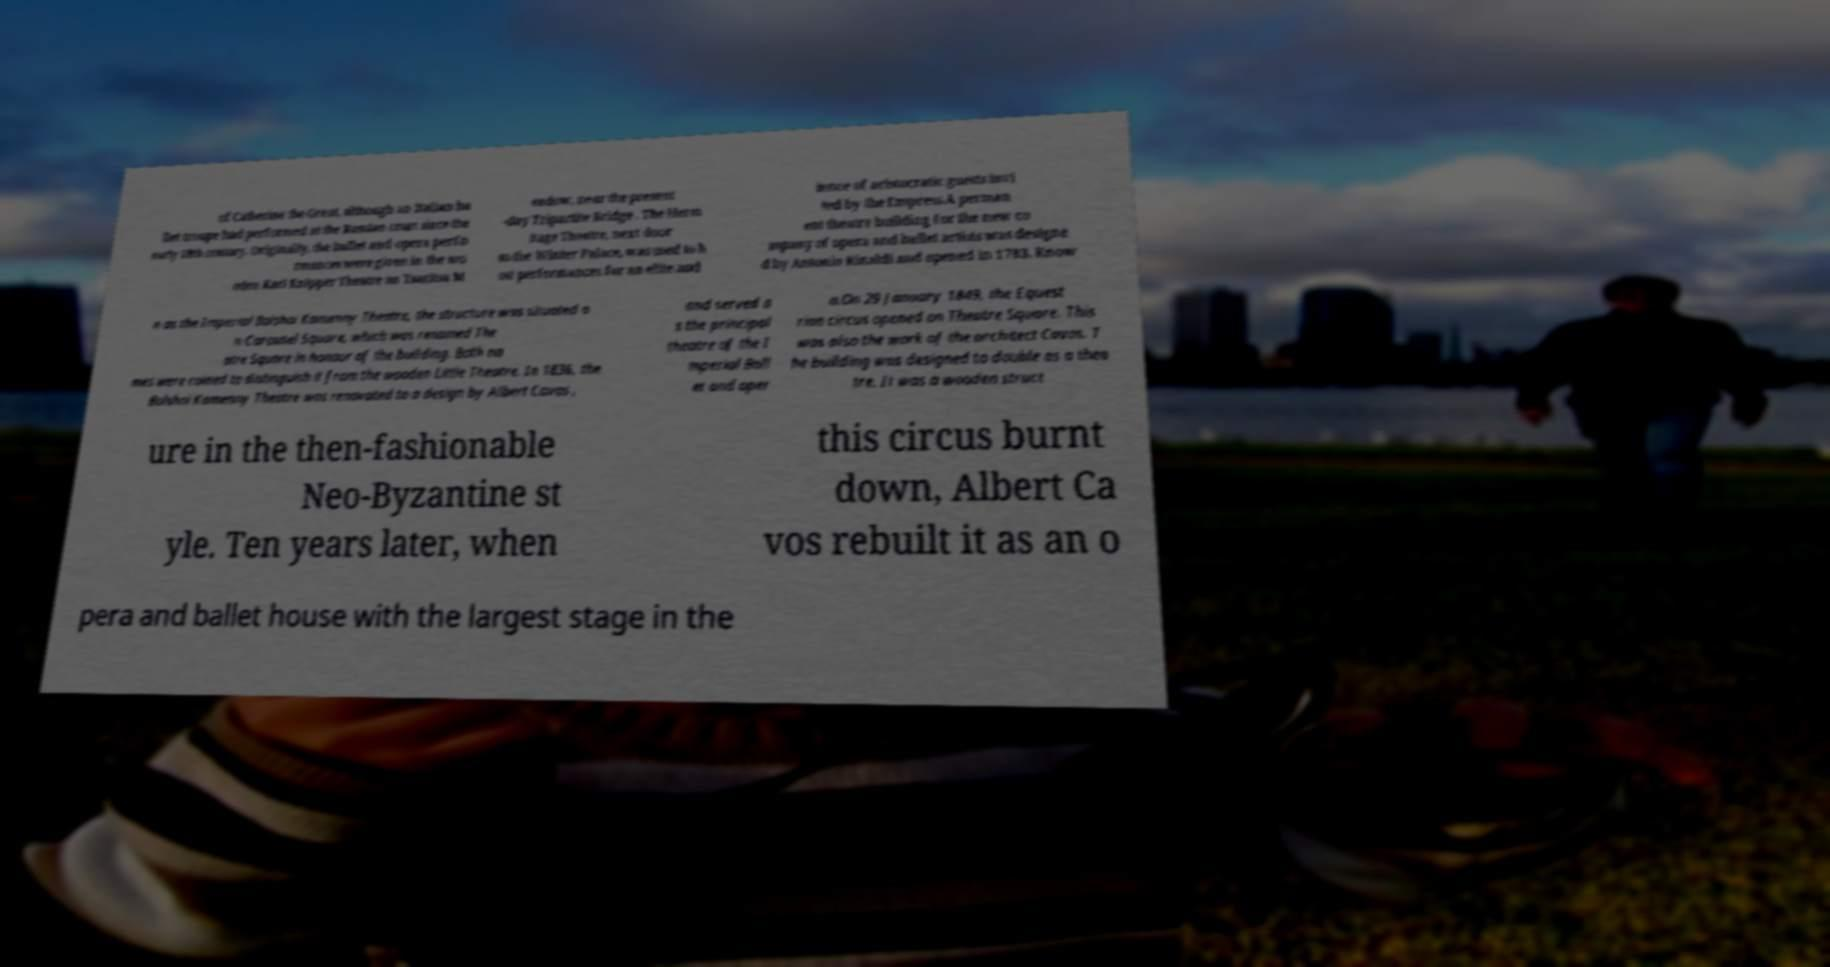What messages or text are displayed in this image? I need them in a readable, typed format. of Catherine the Great, although an Italian ba llet troupe had performed at the Russian court since the early 18th century. Originally, the ballet and opera perfo rmances were given in the wo oden Karl Knipper Theatre on Tsaritsa M eadow, near the present -day Tripartite Bridge . The Herm itage Theatre, next door to the Winter Palace, was used to h ost performances for an elite aud ience of aristocratic guests invi ted by the Empress.A perman ent theatre building for the new co mpany of opera and ballet artists was designe d by Antonio Rinaldi and opened in 1783. Know n as the Imperial Bolshoi Kamenny Theatre, the structure was situated o n Carousel Square, which was renamed The atre Square in honour of the building. Both na mes were coined to distinguish it from the wooden Little Theatre. In 1836, the Bolshoi Kamenny Theatre was renovated to a design by Albert Cavos , and served a s the principal theatre of the I mperial Ball et and oper a.On 29 January 1849, the Equest rian circus opened on Theatre Square. This was also the work of the architect Cavos. T he building was designed to double as a thea tre. It was a wooden struct ure in the then-fashionable Neo-Byzantine st yle. Ten years later, when this circus burnt down, Albert Ca vos rebuilt it as an o pera and ballet house with the largest stage in the 